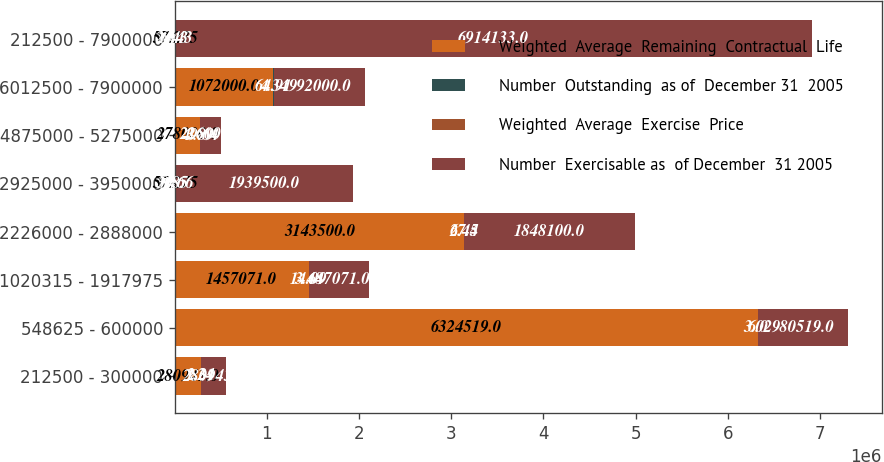<chart> <loc_0><loc_0><loc_500><loc_500><stacked_bar_chart><ecel><fcel>212500 - 300000<fcel>548625 - 600000<fcel>1020315 - 1917975<fcel>2226000 - 2888000<fcel>2925000 - 3950000<fcel>4875000 - 5275000<fcel>6012500 - 7900000<fcel>212500 - 7900000<nl><fcel>Weighted  Average  Remaining  Contractual  Life<fcel>280943<fcel>6.32452e+06<fcel>1.45707e+06<fcel>3.1435e+06<fcel>57.275<fcel>278000<fcel>1.072e+06<fcel>57.275<nl><fcel>Number  Outstanding  as of  December 31  2005<fcel>1.24<fcel>3.02<fcel>3.48<fcel>6.45<fcel>8.85<fcel>3.89<fcel>4.34<fcel>6.43<nl><fcel>Weighted  Average  Exercise  Price<fcel>2.31<fcel>6<fcel>14.09<fcel>27.4<fcel>30.66<fcel>49.64<fcel>64.91<fcel>24.43<nl><fcel>Number  Exercisable as  of December  31 2005<fcel>280943<fcel>980519<fcel>647071<fcel>1.8481e+06<fcel>1.9395e+06<fcel>226000<fcel>992000<fcel>6.91413e+06<nl></chart> 